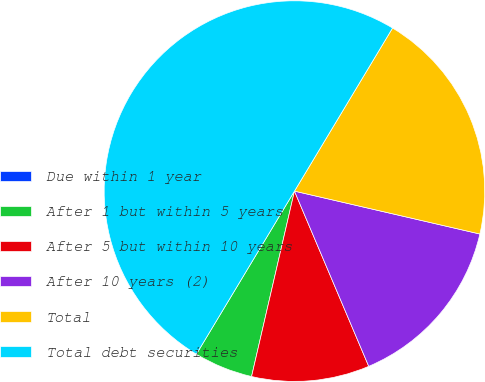<chart> <loc_0><loc_0><loc_500><loc_500><pie_chart><fcel>Due within 1 year<fcel>After 1 but within 5 years<fcel>After 5 but within 10 years<fcel>After 10 years (2)<fcel>Total<fcel>Total debt securities<nl><fcel>0.0%<fcel>5.0%<fcel>10.0%<fcel>15.0%<fcel>20.0%<fcel>50.0%<nl></chart> 